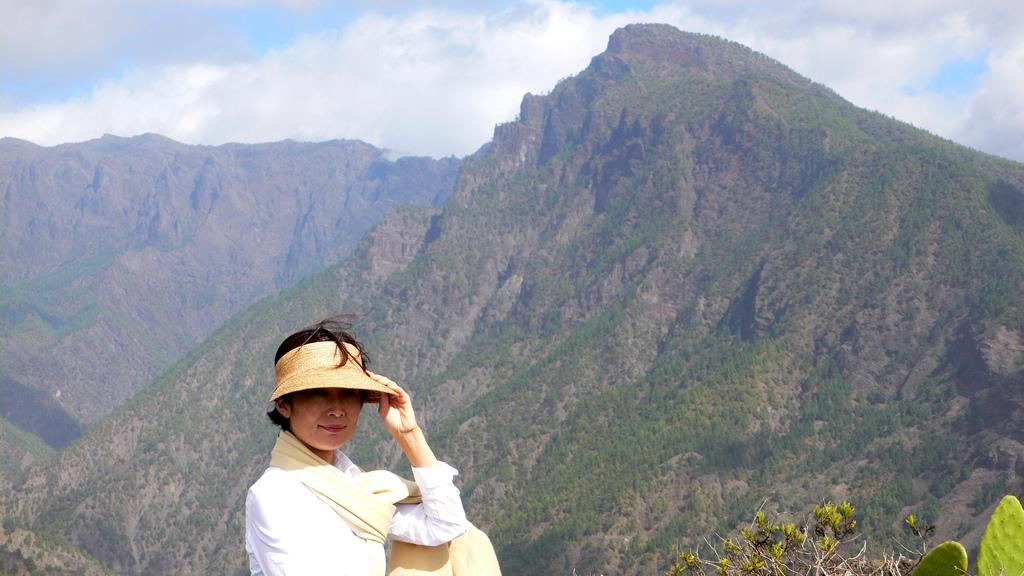Who is present in the image? There is a woman in the image. What is the woman wearing? The woman is wearing a white dress and a hat. What can be seen in the background of the image? There is a mountain and clouds in the background of the image. What type of design can be seen on the woman's shoe in the image? There is no mention of a shoe in the provided facts, so we cannot determine the design on the woman's shoe. 